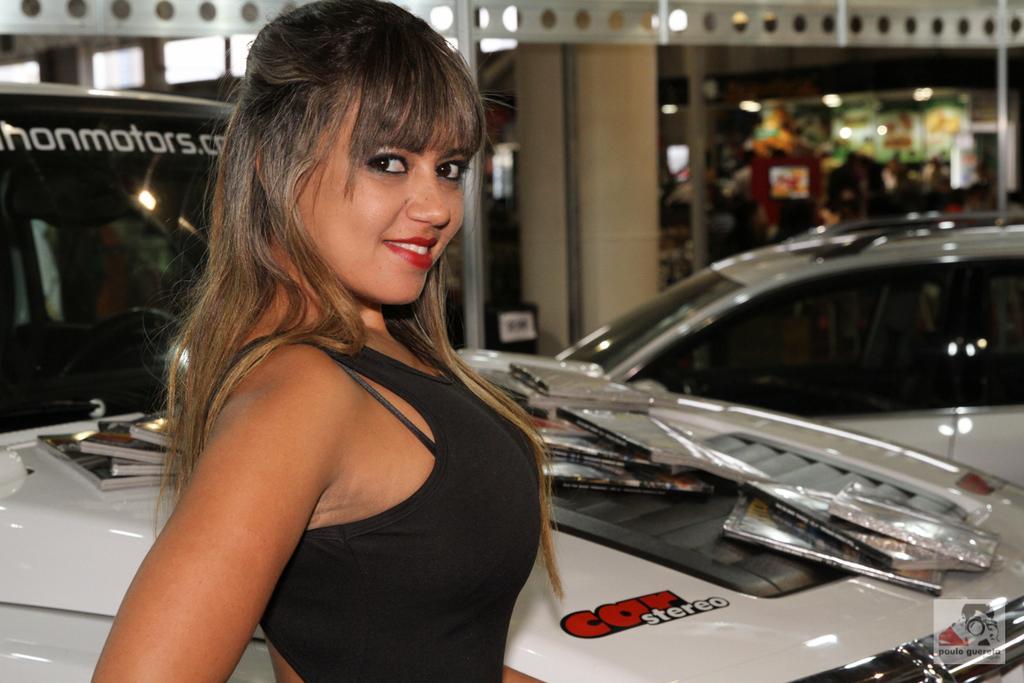Please provide a concise description of this image. There is a woman smiling and we can see vehicles and some objects on this vehicle. In the background it is blurry and we can see lights,wall and rod. 